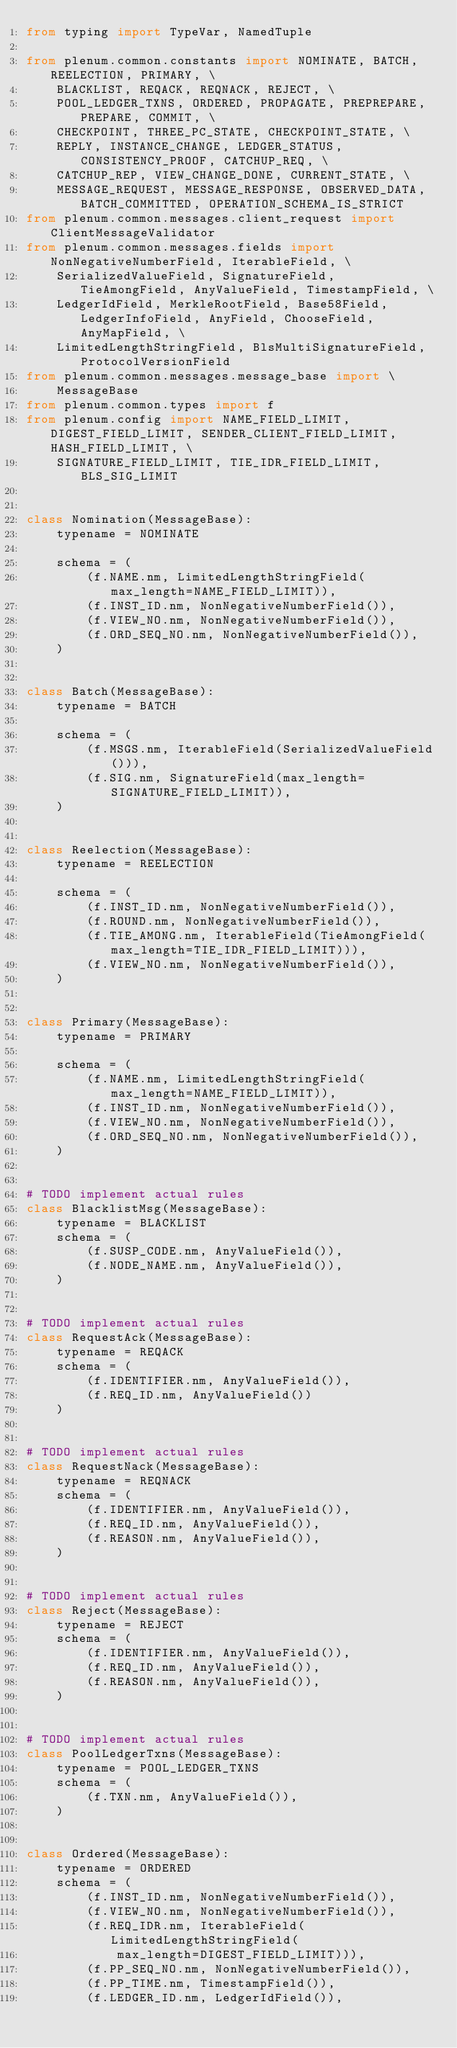<code> <loc_0><loc_0><loc_500><loc_500><_Python_>from typing import TypeVar, NamedTuple

from plenum.common.constants import NOMINATE, BATCH, REELECTION, PRIMARY, \
    BLACKLIST, REQACK, REQNACK, REJECT, \
    POOL_LEDGER_TXNS, ORDERED, PROPAGATE, PREPREPARE, PREPARE, COMMIT, \
    CHECKPOINT, THREE_PC_STATE, CHECKPOINT_STATE, \
    REPLY, INSTANCE_CHANGE, LEDGER_STATUS, CONSISTENCY_PROOF, CATCHUP_REQ, \
    CATCHUP_REP, VIEW_CHANGE_DONE, CURRENT_STATE, \
    MESSAGE_REQUEST, MESSAGE_RESPONSE, OBSERVED_DATA, BATCH_COMMITTED, OPERATION_SCHEMA_IS_STRICT
from plenum.common.messages.client_request import ClientMessageValidator
from plenum.common.messages.fields import NonNegativeNumberField, IterableField, \
    SerializedValueField, SignatureField, TieAmongField, AnyValueField, TimestampField, \
    LedgerIdField, MerkleRootField, Base58Field, LedgerInfoField, AnyField, ChooseField, AnyMapField, \
    LimitedLengthStringField, BlsMultiSignatureField, ProtocolVersionField
from plenum.common.messages.message_base import \
    MessageBase
from plenum.common.types import f
from plenum.config import NAME_FIELD_LIMIT, DIGEST_FIELD_LIMIT, SENDER_CLIENT_FIELD_LIMIT, HASH_FIELD_LIMIT, \
    SIGNATURE_FIELD_LIMIT, TIE_IDR_FIELD_LIMIT, BLS_SIG_LIMIT


class Nomination(MessageBase):
    typename = NOMINATE

    schema = (
        (f.NAME.nm, LimitedLengthStringField(max_length=NAME_FIELD_LIMIT)),
        (f.INST_ID.nm, NonNegativeNumberField()),
        (f.VIEW_NO.nm, NonNegativeNumberField()),
        (f.ORD_SEQ_NO.nm, NonNegativeNumberField()),
    )


class Batch(MessageBase):
    typename = BATCH

    schema = (
        (f.MSGS.nm, IterableField(SerializedValueField())),
        (f.SIG.nm, SignatureField(max_length=SIGNATURE_FIELD_LIMIT)),
    )


class Reelection(MessageBase):
    typename = REELECTION

    schema = (
        (f.INST_ID.nm, NonNegativeNumberField()),
        (f.ROUND.nm, NonNegativeNumberField()),
        (f.TIE_AMONG.nm, IterableField(TieAmongField(max_length=TIE_IDR_FIELD_LIMIT))),
        (f.VIEW_NO.nm, NonNegativeNumberField()),
    )


class Primary(MessageBase):
    typename = PRIMARY

    schema = (
        (f.NAME.nm, LimitedLengthStringField(max_length=NAME_FIELD_LIMIT)),
        (f.INST_ID.nm, NonNegativeNumberField()),
        (f.VIEW_NO.nm, NonNegativeNumberField()),
        (f.ORD_SEQ_NO.nm, NonNegativeNumberField()),
    )


# TODO implement actual rules
class BlacklistMsg(MessageBase):
    typename = BLACKLIST
    schema = (
        (f.SUSP_CODE.nm, AnyValueField()),
        (f.NODE_NAME.nm, AnyValueField()),
    )


# TODO implement actual rules
class RequestAck(MessageBase):
    typename = REQACK
    schema = (
        (f.IDENTIFIER.nm, AnyValueField()),
        (f.REQ_ID.nm, AnyValueField())
    )


# TODO implement actual rules
class RequestNack(MessageBase):
    typename = REQNACK
    schema = (
        (f.IDENTIFIER.nm, AnyValueField()),
        (f.REQ_ID.nm, AnyValueField()),
        (f.REASON.nm, AnyValueField()),
    )


# TODO implement actual rules
class Reject(MessageBase):
    typename = REJECT
    schema = (
        (f.IDENTIFIER.nm, AnyValueField()),
        (f.REQ_ID.nm, AnyValueField()),
        (f.REASON.nm, AnyValueField()),
    )


# TODO implement actual rules
class PoolLedgerTxns(MessageBase):
    typename = POOL_LEDGER_TXNS
    schema = (
        (f.TXN.nm, AnyValueField()),
    )


class Ordered(MessageBase):
    typename = ORDERED
    schema = (
        (f.INST_ID.nm, NonNegativeNumberField()),
        (f.VIEW_NO.nm, NonNegativeNumberField()),
        (f.REQ_IDR.nm, IterableField(LimitedLengthStringField(
            max_length=DIGEST_FIELD_LIMIT))),
        (f.PP_SEQ_NO.nm, NonNegativeNumberField()),
        (f.PP_TIME.nm, TimestampField()),
        (f.LEDGER_ID.nm, LedgerIdField()),</code> 